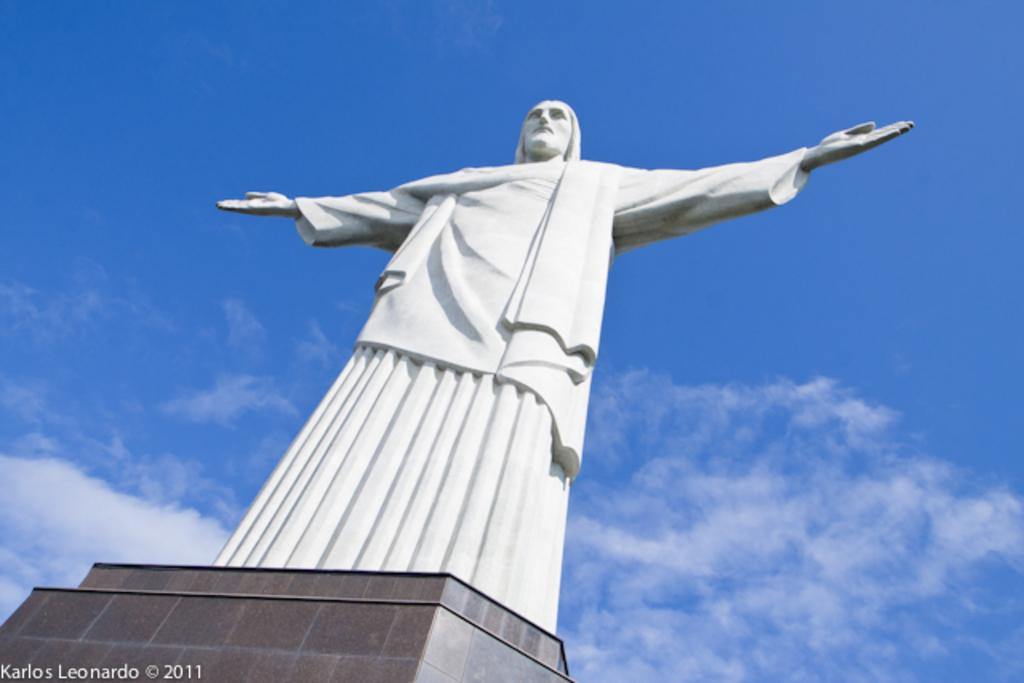What is the main subject of the image? There is a sculpture of a man on a pillar in the image. What can be seen in the background of the image? The sky is visible in the background of the image. Is there any text present in the image? Yes, there is text in the bottom left corner of the image. How many wings does the man in the sculpture have? The sculpture of the man does not have any wings; it is a sculpture of a man without wings. What emotion is the man in the sculpture displaying? The sculpture is a static object and does not display emotions like anger. 